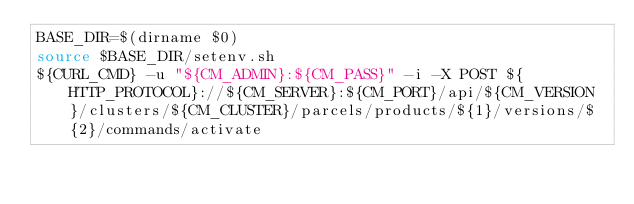<code> <loc_0><loc_0><loc_500><loc_500><_Bash_>BASE_DIR=$(dirname $0)
source $BASE_DIR/setenv.sh
${CURL_CMD} -u "${CM_ADMIN}:${CM_PASS}" -i -X POST ${HTTP_PROTOCOL}://${CM_SERVER}:${CM_PORT}/api/${CM_VERSION}/clusters/${CM_CLUSTER}/parcels/products/${1}/versions/${2}/commands/activate
</code> 